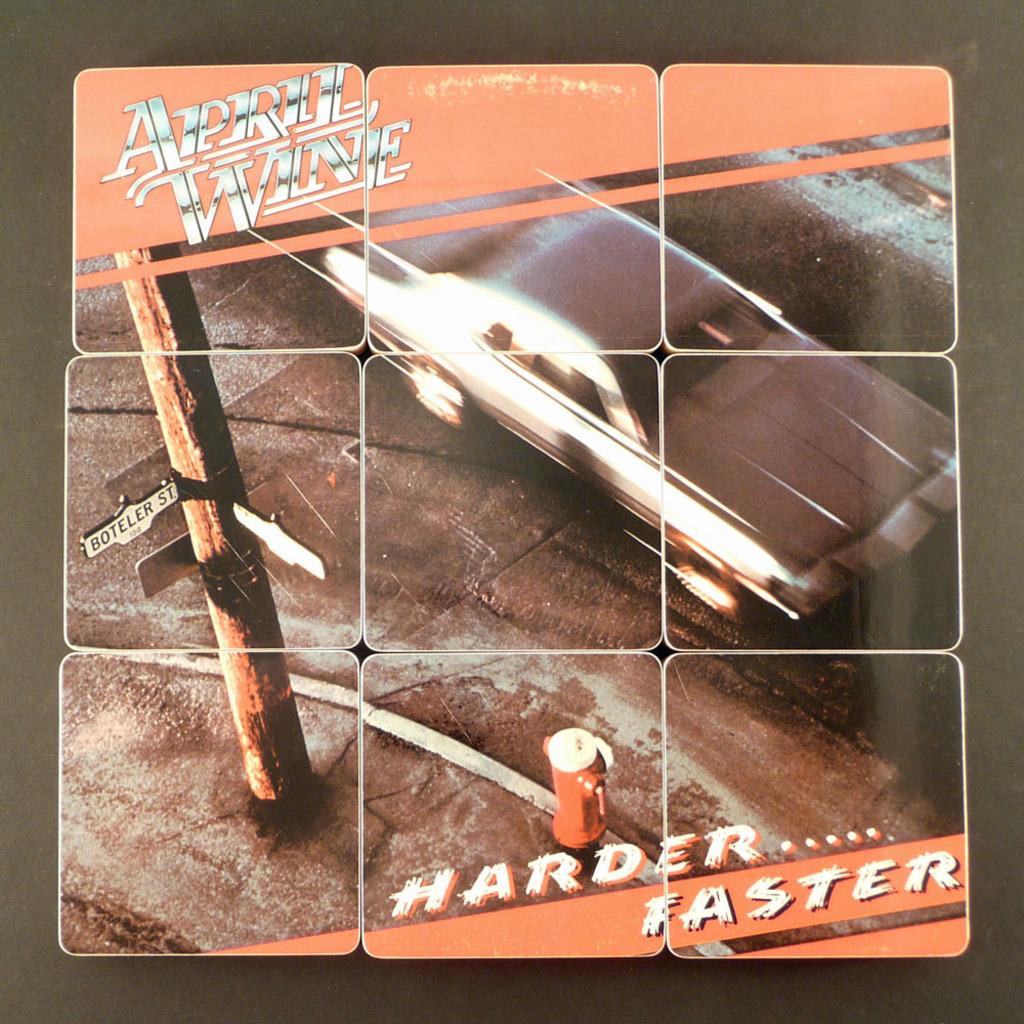What is the name at the top of this album?
Keep it short and to the point. April wine. What does the street sign say?
Give a very brief answer. Boteler st. 